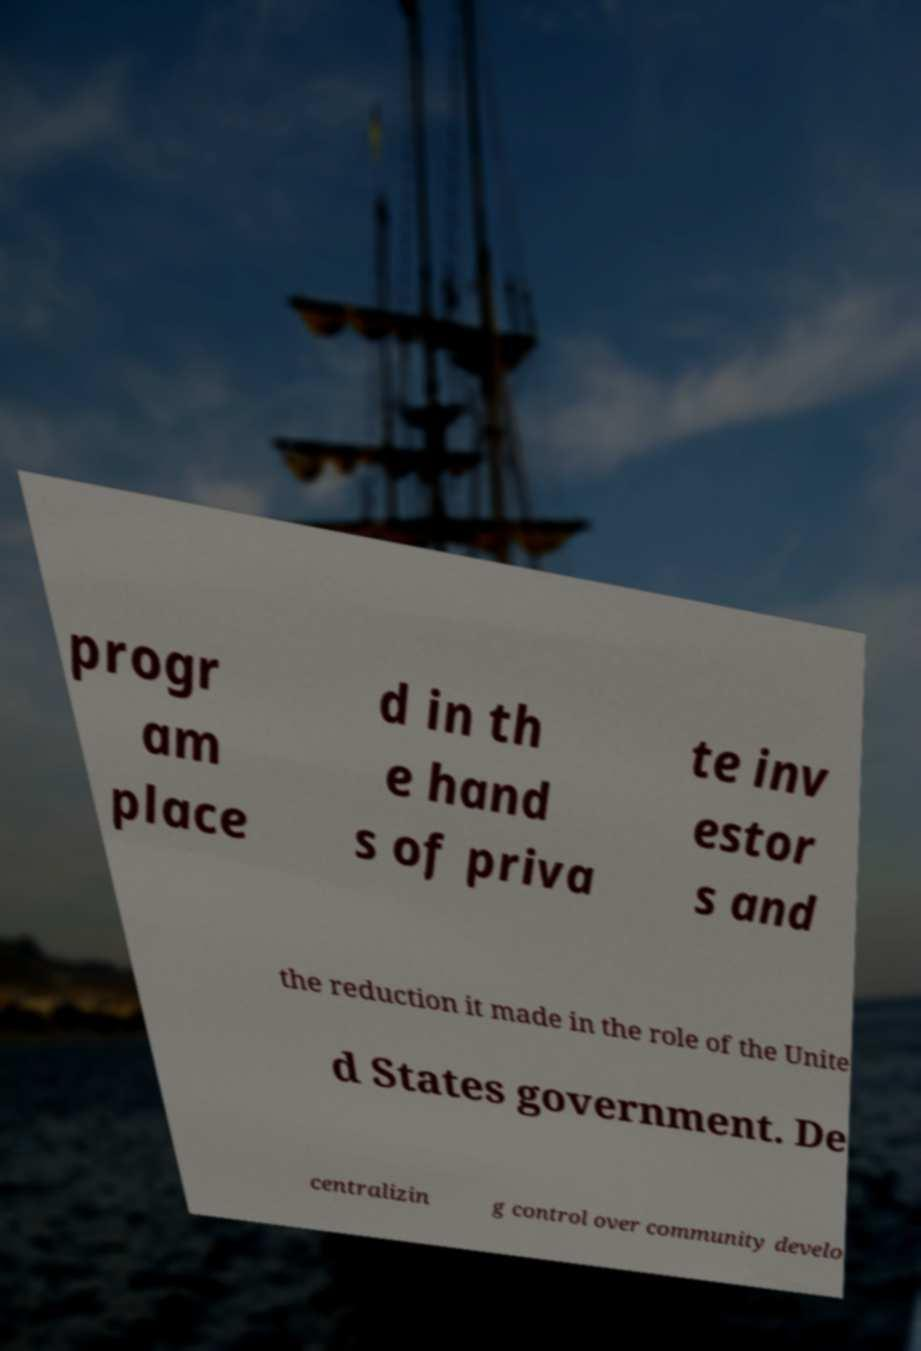Could you extract and type out the text from this image? progr am place d in th e hand s of priva te inv estor s and the reduction it made in the role of the Unite d States government. De centralizin g control over community develo 